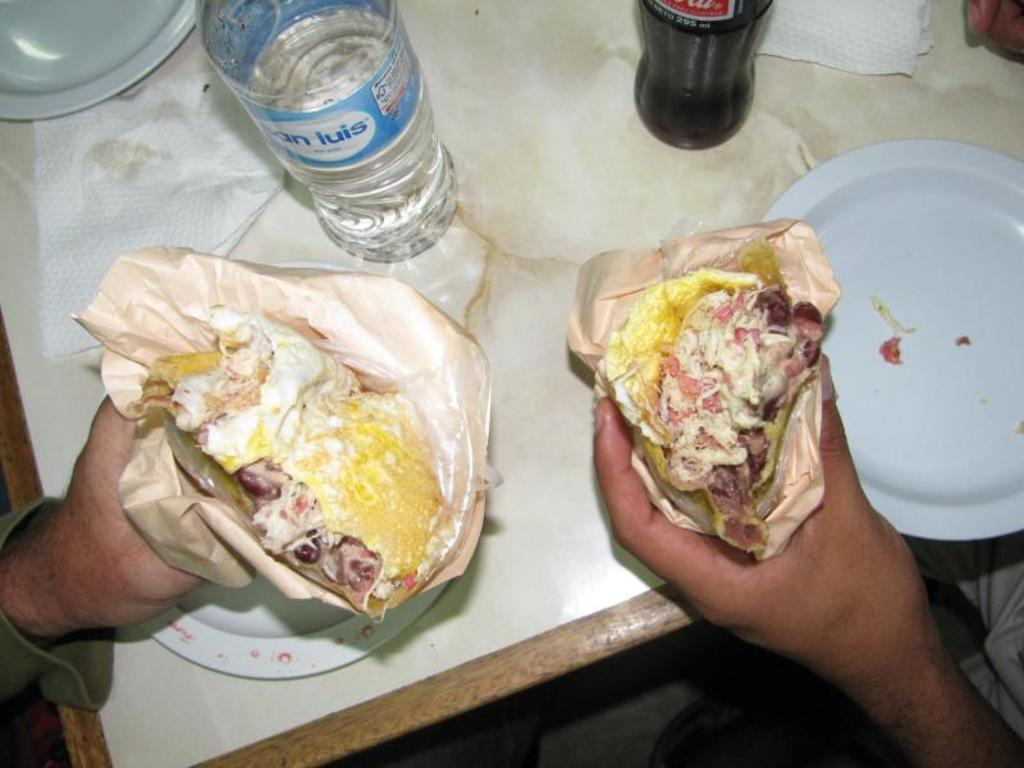What type of food can be seen in the image? There is food in the image, but the specific type cannot be determined from the facts provided. What are the plates used for in the image? The plates are likely used for serving or eating the food in the image. What are the bottles used for in the image? The bottles may contain drinks or other liquids to accompany the food in the image. What can be used for wiping or blowing one's nose in the image? Tissues are present in the image for wiping or blowing one's nose. Where are the objects located in the image? The objects are on a table in the image. Whose hands are visible in the image? Two human hands are visible in the image, but their owner cannot be determined from the facts provided. Can you tell me what year the donkey was born in the image? There is no donkey present in the image, so it is not possible to determine the year of its birth. What type of guitar is being played in the image? There is no guitar present in the image, so it is not possible to determine the type being played. 